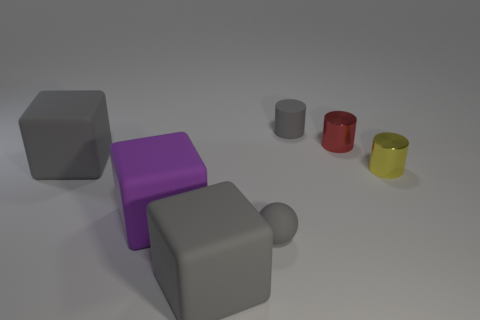How big is the gray matte ball on the right side of the cube that is in front of the tiny gray thing that is left of the small gray cylinder?
Offer a terse response. Small. Are any tiny gray cylinders visible?
Keep it short and to the point. Yes. What is the material of the small object that is the same color as the matte ball?
Ensure brevity in your answer.  Rubber. What number of other tiny spheres are the same color as the rubber ball?
Offer a very short reply. 0. How many things are either small objects that are on the left side of the gray rubber cylinder or large matte things in front of the small yellow shiny cylinder?
Your answer should be very brief. 3. There is a small yellow metallic object that is on the right side of the rubber cylinder; what number of small metallic cylinders are behind it?
Offer a terse response. 1. The tiny ball that is the same material as the small gray cylinder is what color?
Offer a terse response. Gray. Are there any things of the same size as the red cylinder?
Offer a very short reply. Yes. What shape is the gray object that is the same size as the gray sphere?
Your answer should be very brief. Cylinder. Are there any large purple metallic objects of the same shape as the purple matte object?
Your answer should be compact. No. 